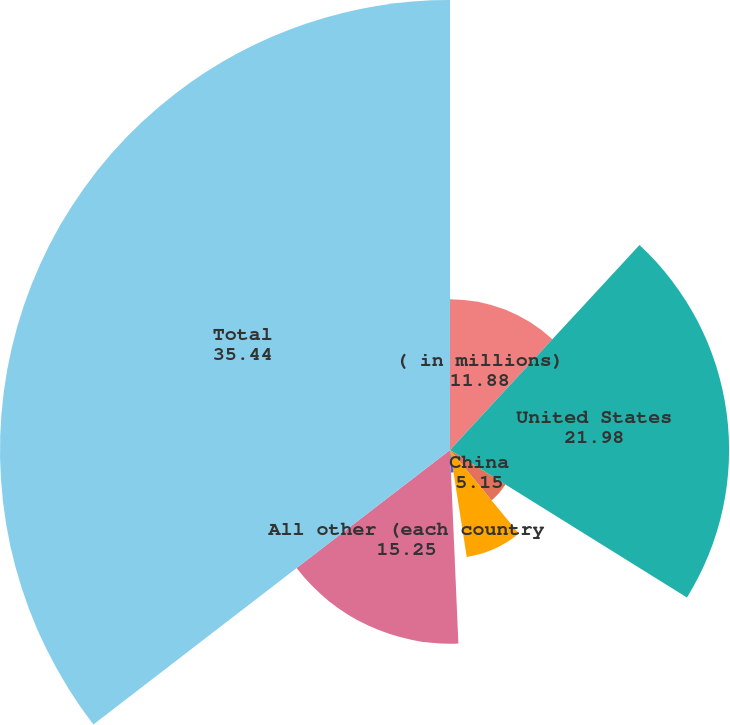Convert chart. <chart><loc_0><loc_0><loc_500><loc_500><pie_chart><fcel>( in millions)<fcel>United States<fcel>China<fcel>Germany<fcel>Japan<fcel>All other (each country<fcel>Total<nl><fcel>11.88%<fcel>21.98%<fcel>5.15%<fcel>8.52%<fcel>1.78%<fcel>15.25%<fcel>35.44%<nl></chart> 